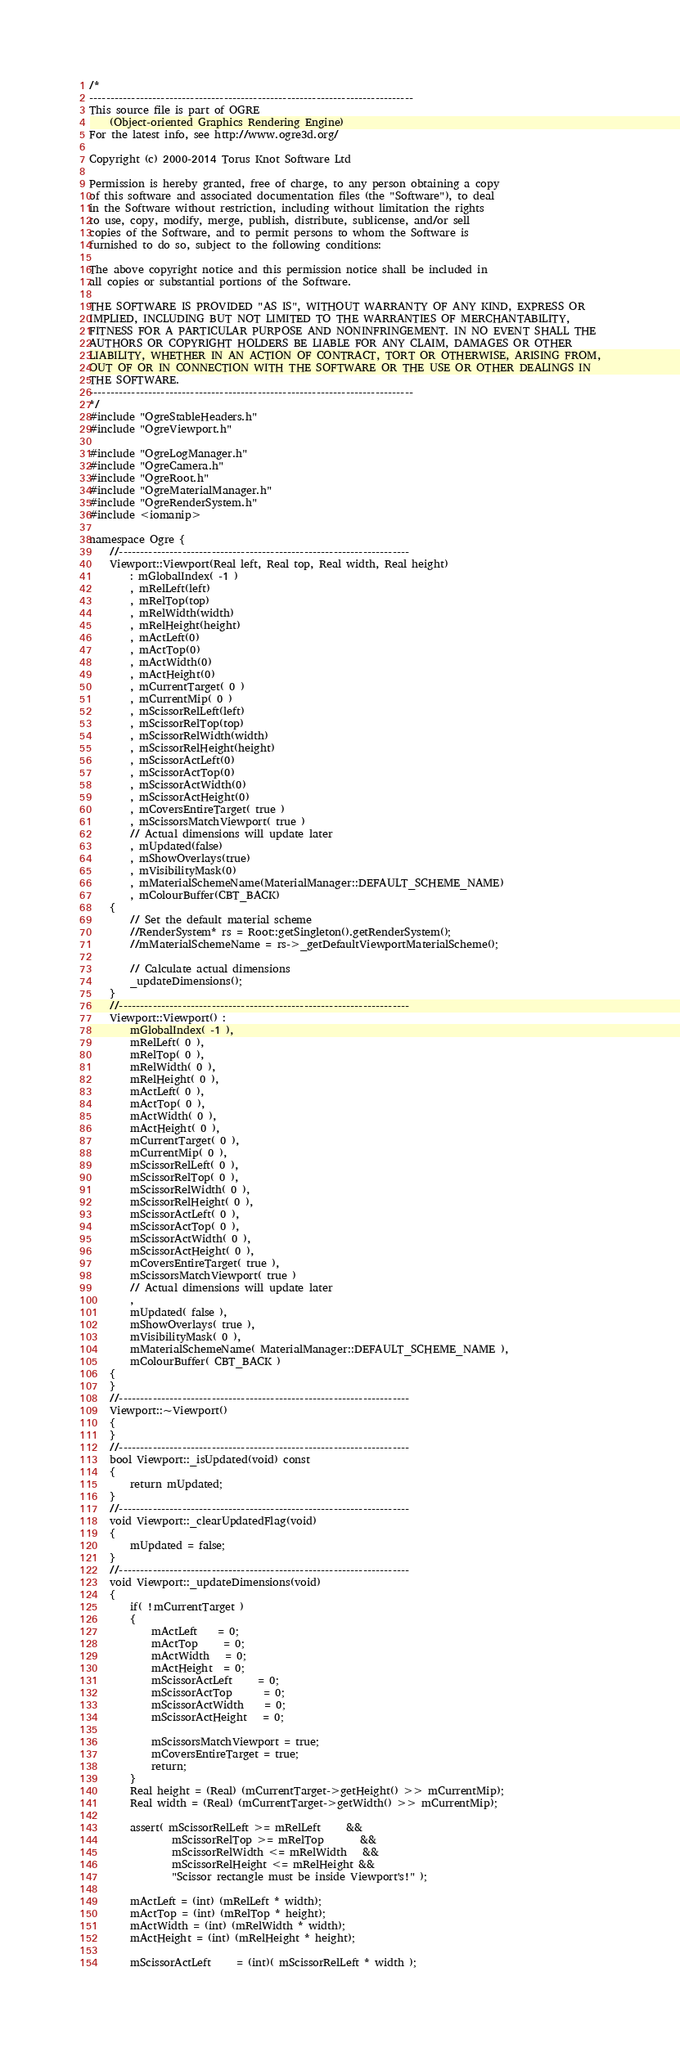<code> <loc_0><loc_0><loc_500><loc_500><_C++_>/*
-----------------------------------------------------------------------------
This source file is part of OGRE
    (Object-oriented Graphics Rendering Engine)
For the latest info, see http://www.ogre3d.org/

Copyright (c) 2000-2014 Torus Knot Software Ltd

Permission is hereby granted, free of charge, to any person obtaining a copy
of this software and associated documentation files (the "Software"), to deal
in the Software without restriction, including without limitation the rights
to use, copy, modify, merge, publish, distribute, sublicense, and/or sell
copies of the Software, and to permit persons to whom the Software is
furnished to do so, subject to the following conditions:

The above copyright notice and this permission notice shall be included in
all copies or substantial portions of the Software.

THE SOFTWARE IS PROVIDED "AS IS", WITHOUT WARRANTY OF ANY KIND, EXPRESS OR
IMPLIED, INCLUDING BUT NOT LIMITED TO THE WARRANTIES OF MERCHANTABILITY,
FITNESS FOR A PARTICULAR PURPOSE AND NONINFRINGEMENT. IN NO EVENT SHALL THE
AUTHORS OR COPYRIGHT HOLDERS BE LIABLE FOR ANY CLAIM, DAMAGES OR OTHER
LIABILITY, WHETHER IN AN ACTION OF CONTRACT, TORT OR OTHERWISE, ARISING FROM,
OUT OF OR IN CONNECTION WITH THE SOFTWARE OR THE USE OR OTHER DEALINGS IN
THE SOFTWARE.
-----------------------------------------------------------------------------
*/
#include "OgreStableHeaders.h"
#include "OgreViewport.h"

#include "OgreLogManager.h"
#include "OgreCamera.h"
#include "OgreRoot.h"
#include "OgreMaterialManager.h"
#include "OgreRenderSystem.h"
#include <iomanip>

namespace Ogre {
    //---------------------------------------------------------------------
    Viewport::Viewport(Real left, Real top, Real width, Real height)
        : mGlobalIndex( -1 )
        , mRelLeft(left)
        , mRelTop(top)
        , mRelWidth(width)
        , mRelHeight(height)
        , mActLeft(0)
        , mActTop(0)
        , mActWidth(0)
        , mActHeight(0)
        , mCurrentTarget( 0 )
        , mCurrentMip( 0 )
        , mScissorRelLeft(left)
        , mScissorRelTop(top)
        , mScissorRelWidth(width)
        , mScissorRelHeight(height)
        , mScissorActLeft(0)
        , mScissorActTop(0)
        , mScissorActWidth(0)
        , mScissorActHeight(0)
        , mCoversEntireTarget( true )
        , mScissorsMatchViewport( true )
        // Actual dimensions will update later
        , mUpdated(false)
        , mShowOverlays(true)
        , mVisibilityMask(0)
        , mMaterialSchemeName(MaterialManager::DEFAULT_SCHEME_NAME)
        , mColourBuffer(CBT_BACK)
    {
        // Set the default material scheme
        //RenderSystem* rs = Root::getSingleton().getRenderSystem();
        //mMaterialSchemeName = rs->_getDefaultViewportMaterialScheme();
        
        // Calculate actual dimensions
        _updateDimensions();
    }
    //---------------------------------------------------------------------
    Viewport::Viewport() :
        mGlobalIndex( -1 ),
        mRelLeft( 0 ),
        mRelTop( 0 ),
        mRelWidth( 0 ),
        mRelHeight( 0 ),
        mActLeft( 0 ),
        mActTop( 0 ),
        mActWidth( 0 ),
        mActHeight( 0 ),
        mCurrentTarget( 0 ),
        mCurrentMip( 0 ),
        mScissorRelLeft( 0 ),
        mScissorRelTop( 0 ),
        mScissorRelWidth( 0 ),
        mScissorRelHeight( 0 ),
        mScissorActLeft( 0 ),
        mScissorActTop( 0 ),
        mScissorActWidth( 0 ),
        mScissorActHeight( 0 ),
        mCoversEntireTarget( true ),
        mScissorsMatchViewport( true )
        // Actual dimensions will update later
        ,
        mUpdated( false ),
        mShowOverlays( true ),
        mVisibilityMask( 0 ),
        mMaterialSchemeName( MaterialManager::DEFAULT_SCHEME_NAME ),
        mColourBuffer( CBT_BACK )
    {
    }
    //---------------------------------------------------------------------
    Viewport::~Viewport()
    {
    }
    //---------------------------------------------------------------------
    bool Viewport::_isUpdated(void) const
    {
        return mUpdated;
    }
    //---------------------------------------------------------------------
    void Viewport::_clearUpdatedFlag(void)
    {
        mUpdated = false;
    }
    //---------------------------------------------------------------------
    void Viewport::_updateDimensions(void)
    {
        if( !mCurrentTarget )
        {
            mActLeft    = 0;
            mActTop     = 0;
            mActWidth   = 0;
            mActHeight  = 0;
            mScissorActLeft     = 0;
            mScissorActTop      = 0;
            mScissorActWidth    = 0;
            mScissorActHeight   = 0;

            mScissorsMatchViewport = true;
            mCoversEntireTarget = true;
            return;
        }
        Real height = (Real) (mCurrentTarget->getHeight() >> mCurrentMip);
        Real width = (Real) (mCurrentTarget->getWidth() >> mCurrentMip);

        assert( mScissorRelLeft >= mRelLeft     &&
                mScissorRelTop >= mRelTop       &&
                mScissorRelWidth <= mRelWidth   &&
                mScissorRelHeight <= mRelHeight &&
                "Scissor rectangle must be inside Viewport's!" );

        mActLeft = (int) (mRelLeft * width);
        mActTop = (int) (mRelTop * height);
        mActWidth = (int) (mRelWidth * width);
        mActHeight = (int) (mRelHeight * height);

        mScissorActLeft     = (int)( mScissorRelLeft * width );</code> 